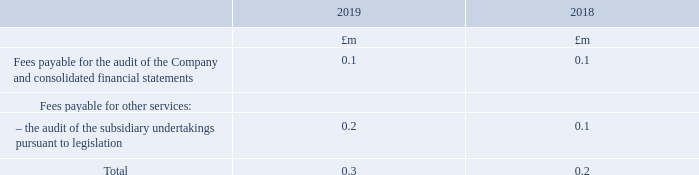Services provided by the Company’s auditors
During the year, the Group (including overseas subsidiaries) obtained the following services from the operating company’s auditors:
What was the total amount of fees payable in 2019?
Answer scale should be: million. 0.3. What do the fees payable for other services relate to? The audit of the subsidiary undertakings pursuant to legislation. What do the fees in the table relate to? Services provided by the company’s auditors. In which year was the total amount of fees payable larger? 0.3>0.2
Answer: 2019. What was the change in the total amount of fees payable in 2019 from 2018?
Answer scale should be: million. 0.3-0.2
Answer: 0.1. What was the percentage change in the total amount of fees payable in 2019 from 2018?
Answer scale should be: percent. (0.3-0.2)/0.2
Answer: 50. 